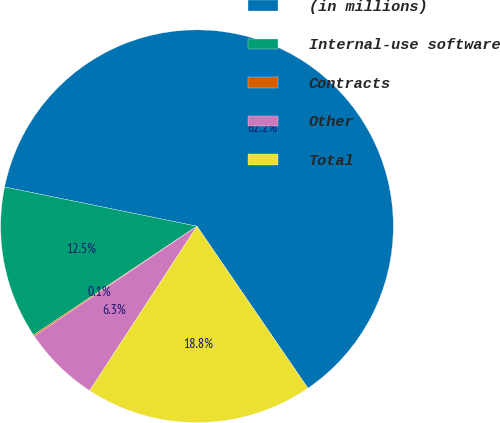Convert chart. <chart><loc_0><loc_0><loc_500><loc_500><pie_chart><fcel>(in millions)<fcel>Internal-use software<fcel>Contracts<fcel>Other<fcel>Total<nl><fcel>62.24%<fcel>12.55%<fcel>0.12%<fcel>6.33%<fcel>18.76%<nl></chart> 